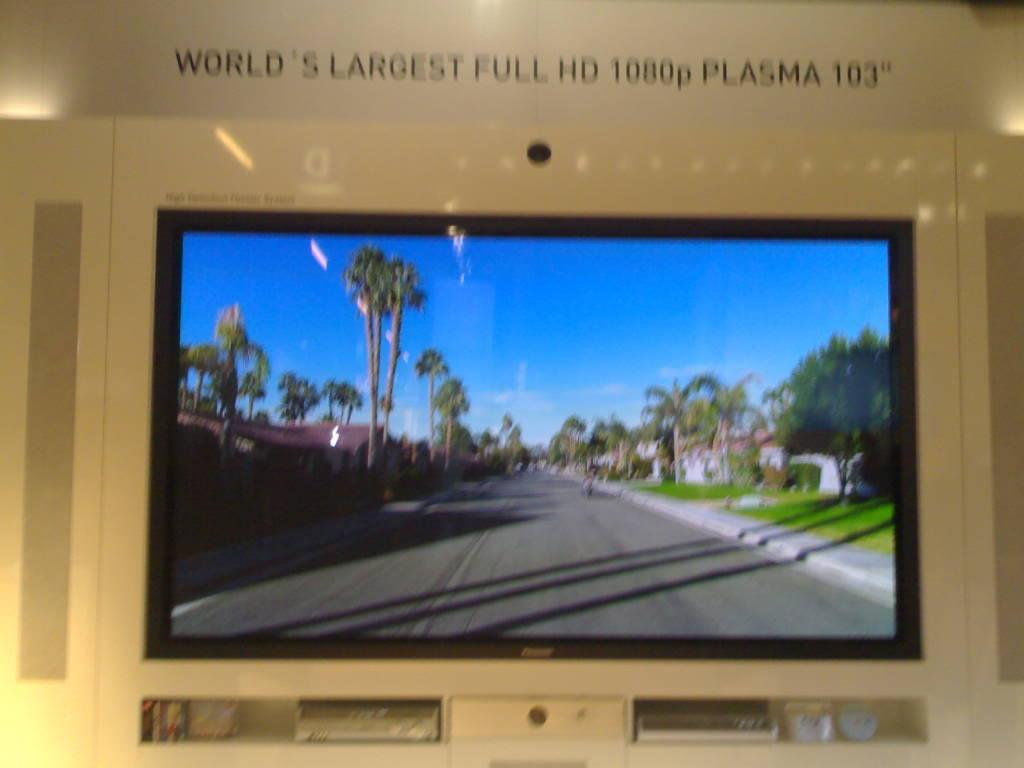<image>
Give a short and clear explanation of the subsequent image. A television is below the sentence World's Largest Full HD 1080p Plasma 103" on the wall. 